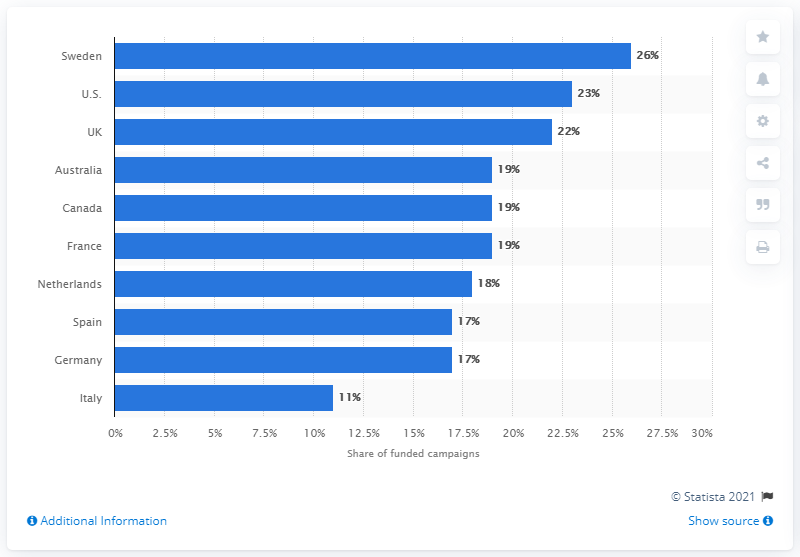Identify some key points in this picture. In 2016, out of the total number of crowdfunding campaigns that were launched in Sweden, approximately 26% of them were successful and received funding. 